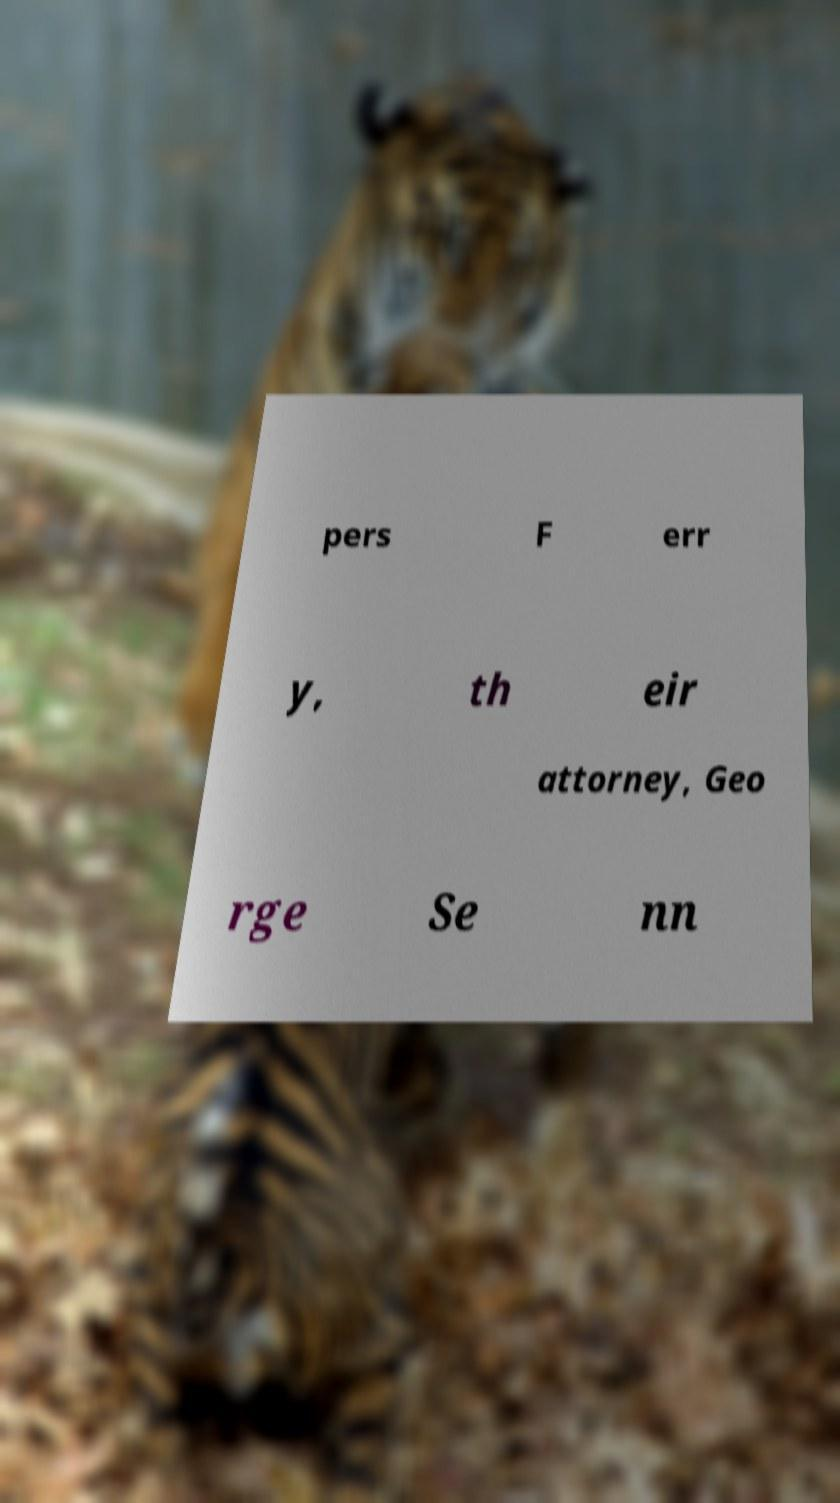For documentation purposes, I need the text within this image transcribed. Could you provide that? pers F err y, th eir attorney, Geo rge Se nn 